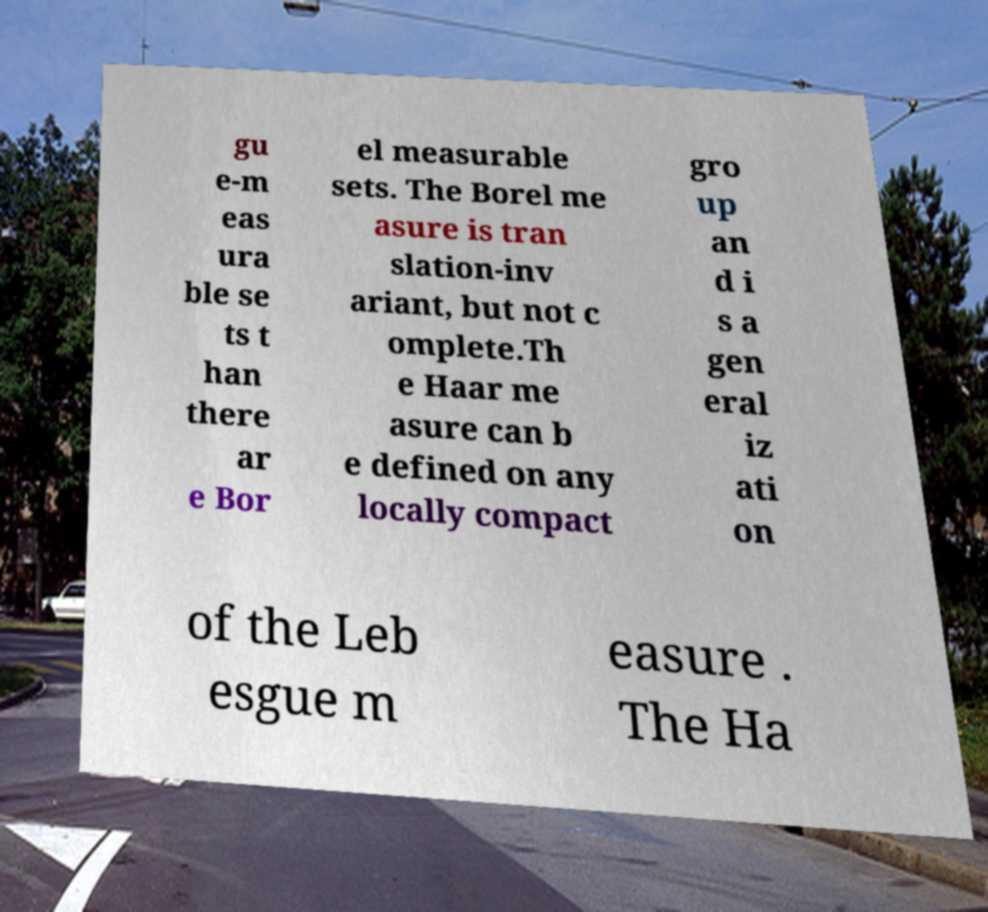I need the written content from this picture converted into text. Can you do that? gu e-m eas ura ble se ts t han there ar e Bor el measurable sets. The Borel me asure is tran slation-inv ariant, but not c omplete.Th e Haar me asure can b e defined on any locally compact gro up an d i s a gen eral iz ati on of the Leb esgue m easure . The Ha 